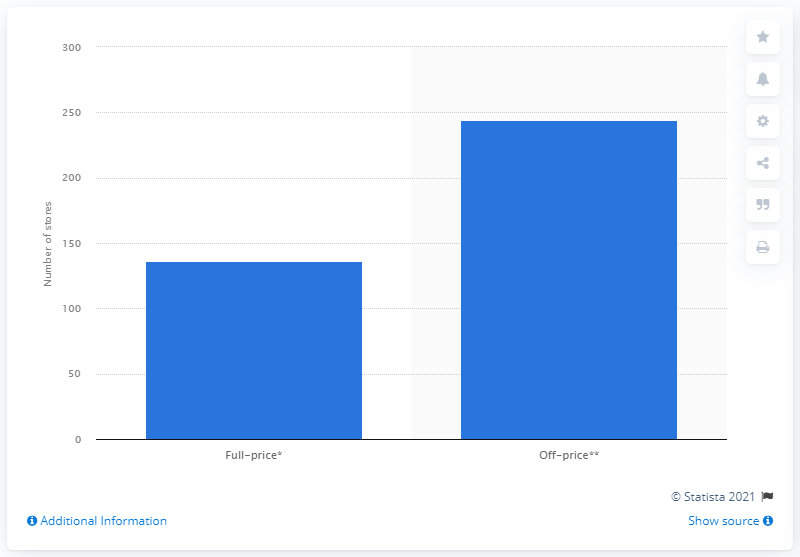List a handful of essential elements in this visual. As of February 1, 2020, Nordstrom had a total of 136 full-price department stores. 